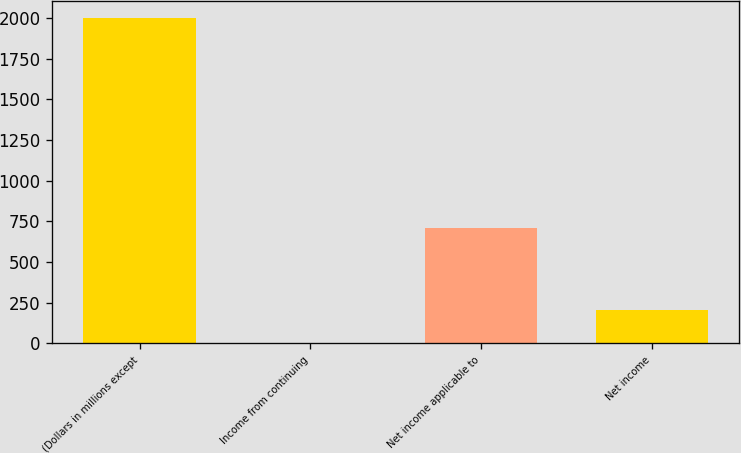Convert chart. <chart><loc_0><loc_0><loc_500><loc_500><bar_chart><fcel>(Dollars in millions except<fcel>Income from continuing<fcel>Net income applicable to<fcel>Net income<nl><fcel>2002<fcel>1.63<fcel>707.04<fcel>201.67<nl></chart> 